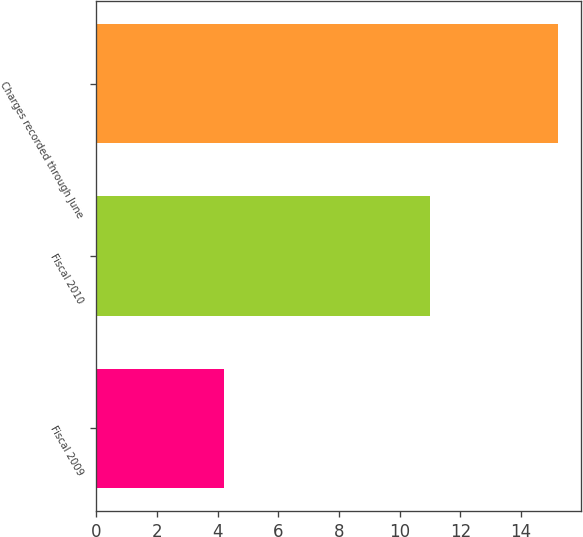Convert chart to OTSL. <chart><loc_0><loc_0><loc_500><loc_500><bar_chart><fcel>Fiscal 2009<fcel>Fiscal 2010<fcel>Charges recorded through June<nl><fcel>4.2<fcel>11<fcel>15.2<nl></chart> 